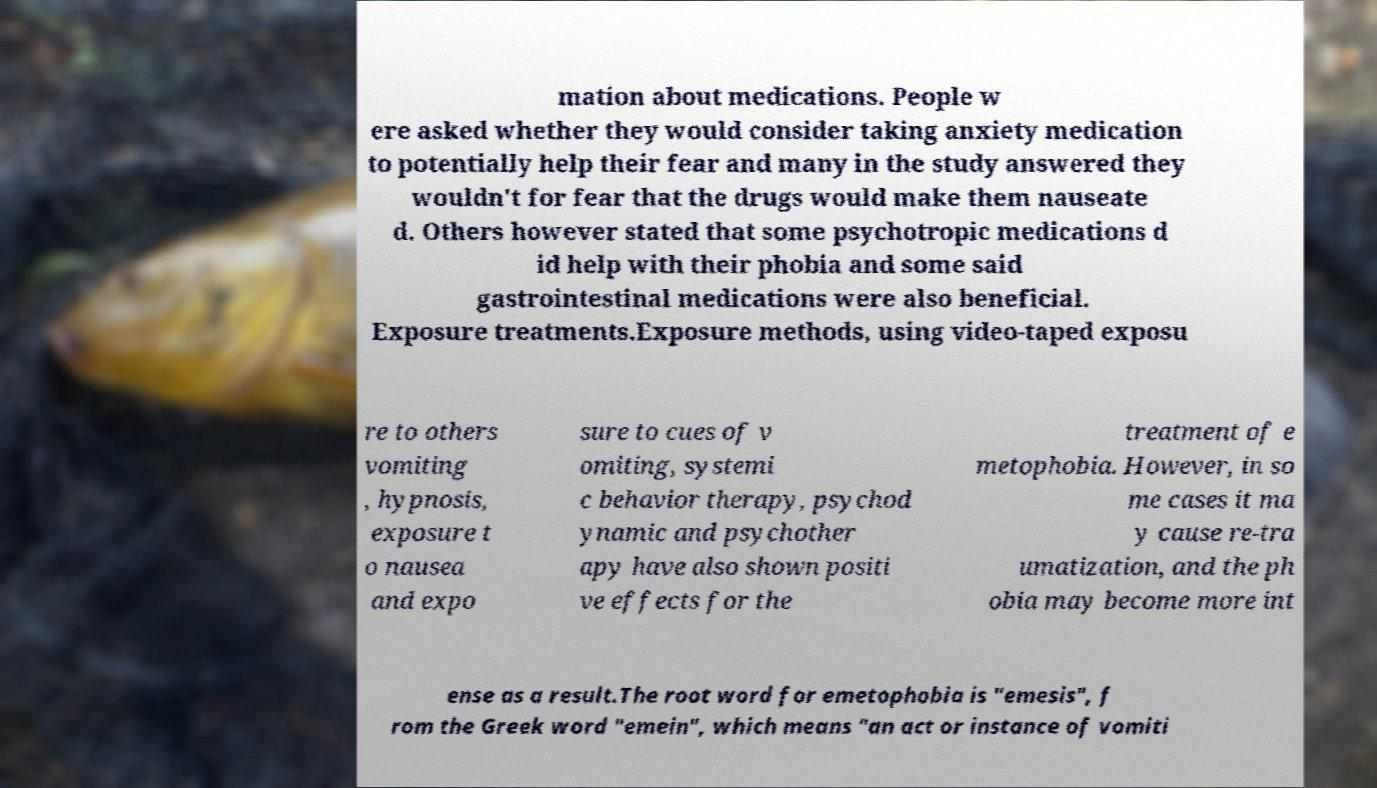What messages or text are displayed in this image? I need them in a readable, typed format. mation about medications. People w ere asked whether they would consider taking anxiety medication to potentially help their fear and many in the study answered they wouldn't for fear that the drugs would make them nauseate d. Others however stated that some psychotropic medications d id help with their phobia and some said gastrointestinal medications were also beneficial. Exposure treatments.Exposure methods, using video-taped exposu re to others vomiting , hypnosis, exposure t o nausea and expo sure to cues of v omiting, systemi c behavior therapy, psychod ynamic and psychother apy have also shown positi ve effects for the treatment of e metophobia. However, in so me cases it ma y cause re-tra umatization, and the ph obia may become more int ense as a result.The root word for emetophobia is "emesis", f rom the Greek word "emein", which means "an act or instance of vomiti 